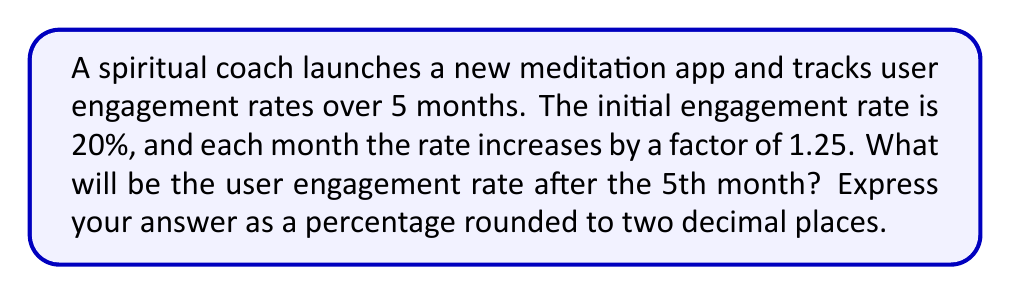Give your solution to this math problem. Let's approach this step-by-step:

1) We're dealing with a geometric progression where:
   - Initial term (a) = 20% = 0.20
   - Common ratio (r) = 1.25
   - Number of terms (n) = 5

2) In a geometric progression, the nth term is given by the formula:
   $$a_n = a \cdot r^{n-1}$$

3) We want to find the 5th term, so n = 5:
   $$a_5 = 0.20 \cdot 1.25^{5-1}$$

4) Let's calculate:
   $$a_5 = 0.20 \cdot 1.25^4$$
   $$a_5 = 0.20 \cdot 2.44140625$$
   $$a_5 = 0.48828125$$

5) Converting to a percentage:
   $$0.48828125 \cdot 100 = 48.828125\%$$

6) Rounding to two decimal places:
   $$48.83\%$$
Answer: 48.83% 